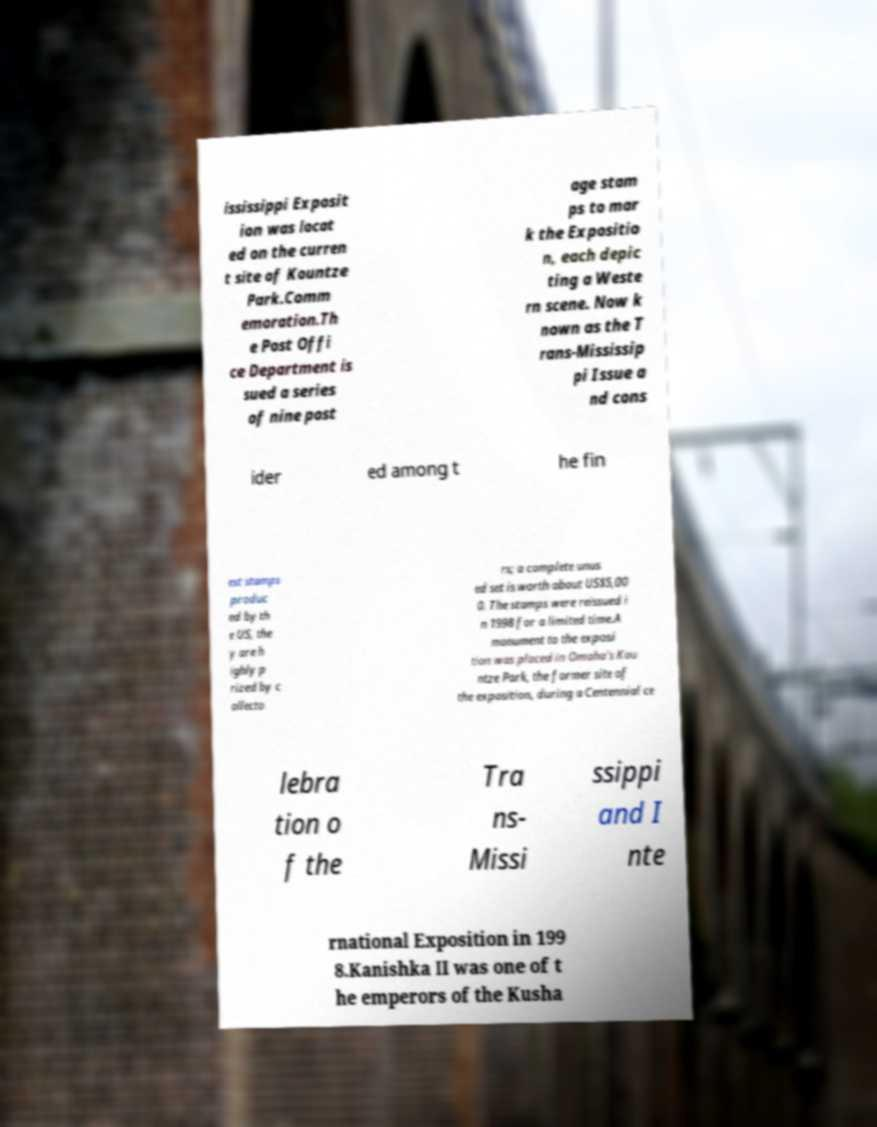I need the written content from this picture converted into text. Can you do that? ississippi Exposit ion was locat ed on the curren t site of Kountze Park.Comm emoration.Th e Post Offi ce Department is sued a series of nine post age stam ps to mar k the Expositio n, each depic ting a Weste rn scene. Now k nown as the T rans-Mississip pi Issue a nd cons ider ed among t he fin est stamps produc ed by th e US, the y are h ighly p rized by c ollecto rs; a complete unus ed set is worth about US$5,00 0. The stamps were reissued i n 1998 for a limited time.A monument to the exposi tion was placed in Omaha's Kou ntze Park, the former site of the exposition, during a Centennial ce lebra tion o f the Tra ns- Missi ssippi and I nte rnational Exposition in 199 8.Kanishka II was one of t he emperors of the Kusha 